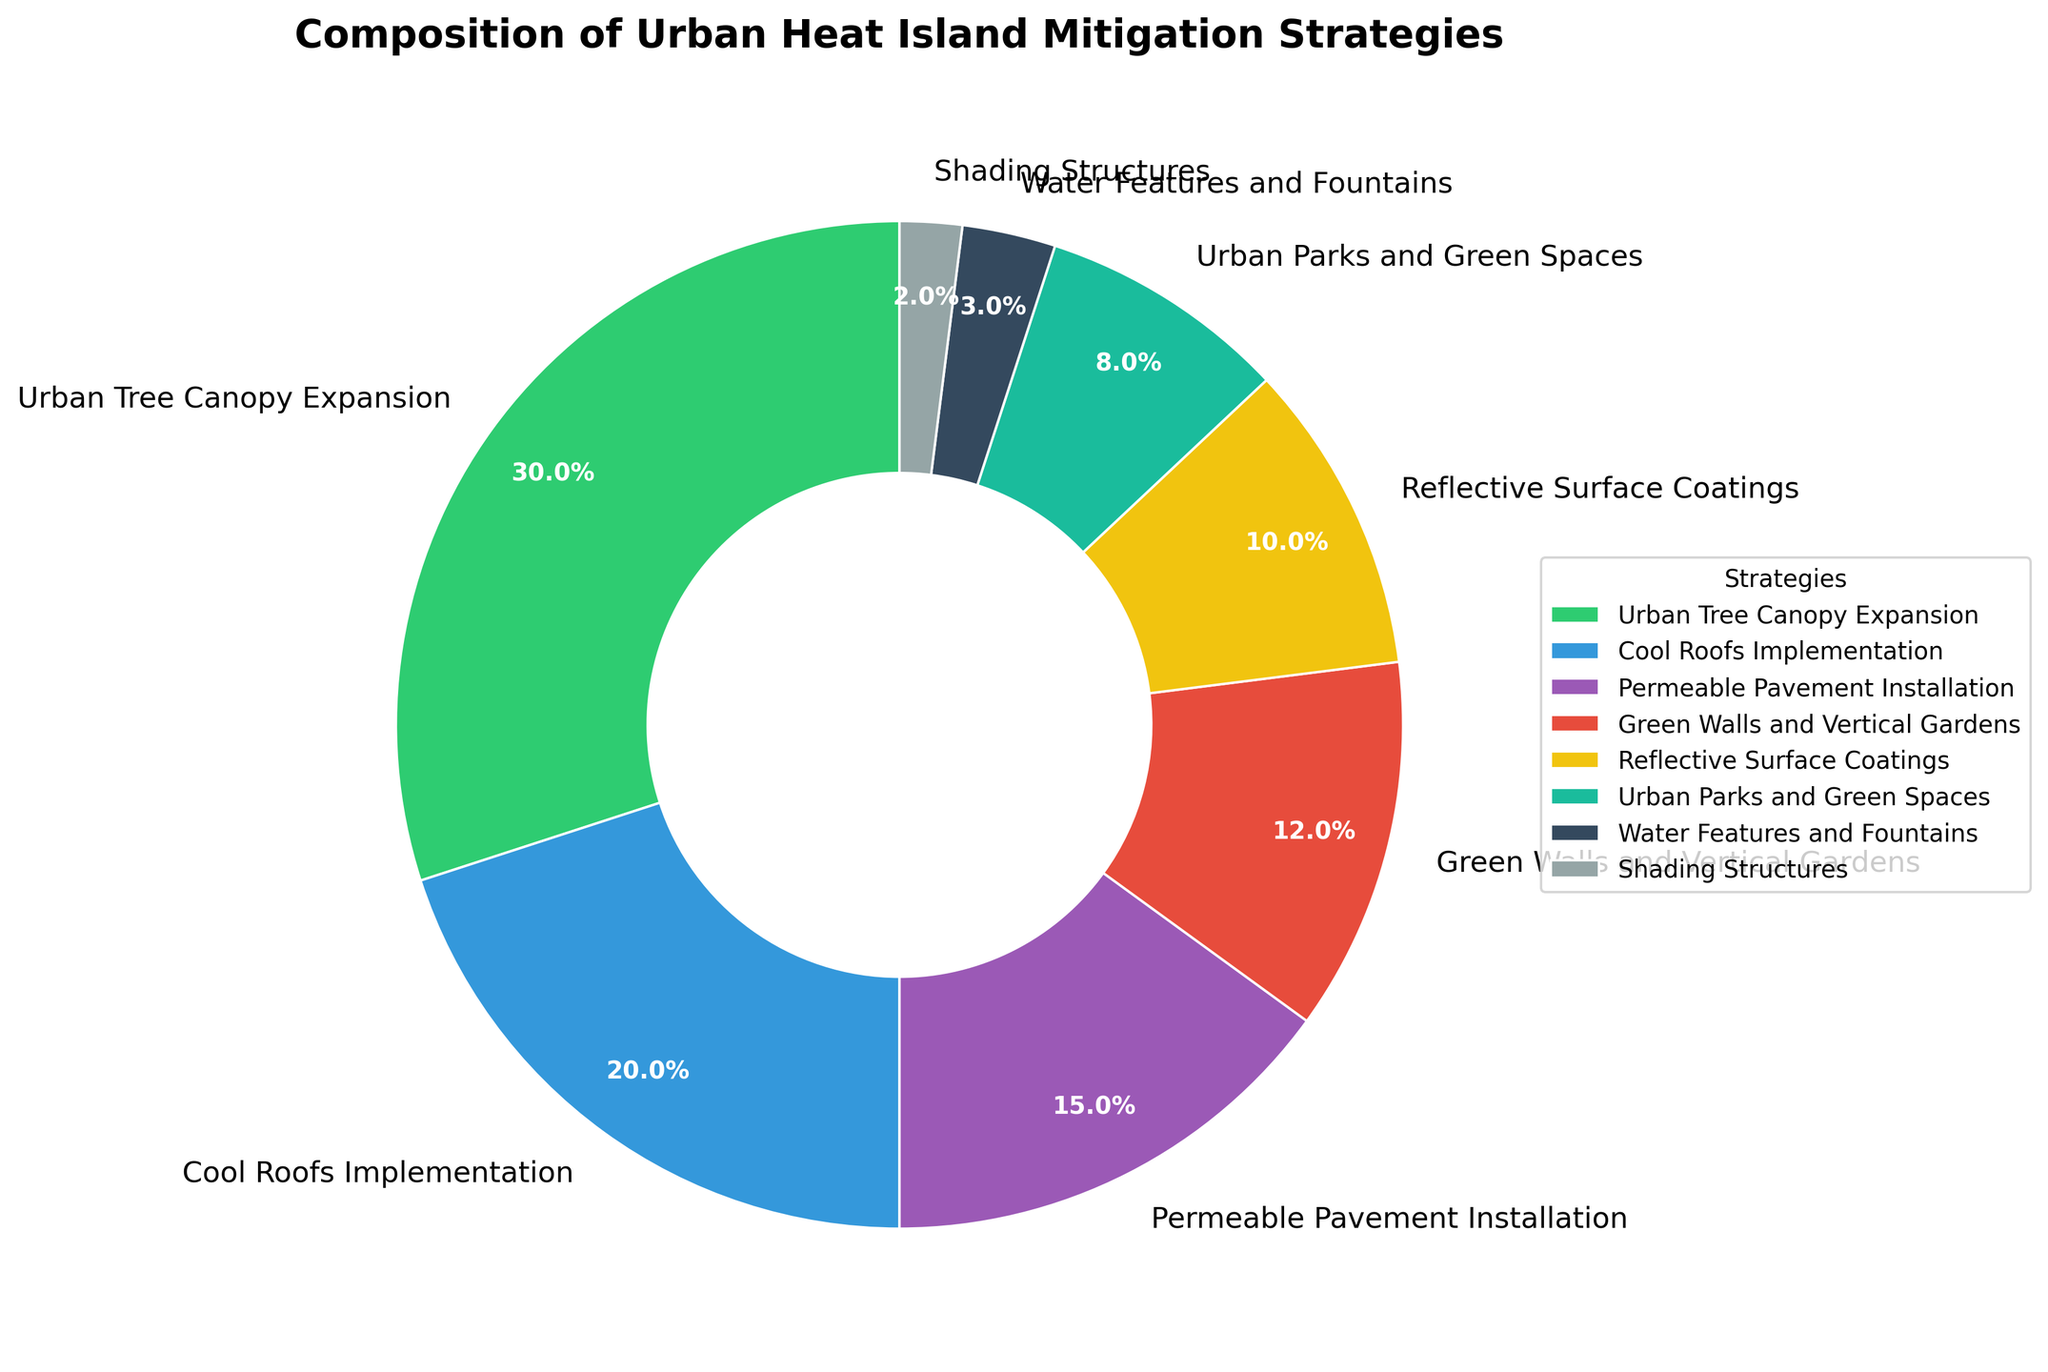What strategy represents the largest percentage of urban heat island mitigation? The visual attributes such as size and label of the pie wedges indicate percentages. The largest segment is labeled 'Urban Tree Canopy Expansion' with 30%.
Answer: Urban Tree Canopy Expansion Which two strategies combined make up less than 10%? Identify segments with the smallest percentages. 'Shading Structures' is 2% and 'Water Features and Fountains' is 3%. Adding them, 2% + 3% equals 5%, which is less than 10%.
Answer: Shading Structures and Water Features and Fountains Is the percentage of 'Cool Roofs Implementation' greater than 'Urban Parks and Green Spaces'? Compare 'Cool Roofs Implementation' at 20% directly with 'Urban Parks and Green Spaces' at 8%. 20% is greater than 8%.
Answer: Yes How much more percentage does 'Permeable Pavement Installation' have compared to 'Reflective Surface Coatings'? Subtract 'Reflective Surface Coatings' percentage from 'Permeable Pavement Installation's percentage. 15% - 10% equals 5%.
Answer: 5% Which strategies are represented by the green and blue pie segments? Identify the segments' colors related to strategies. Green is 'Urban Tree Canopy Expansion' and blue is 'Cool Roofs Implementation'.
Answer: Urban Tree Canopy Expansion and Cool Roofs Implementation What's the combined percentage of 'Green Walls and Vertical Gardens' and 'Water Features and Fountains'? Add the percentages of 'Green Walls and Vertical Gardens' at 12% and 'Water Features and Fountains' at 3%. 12% + 3% equals 15%.
Answer: 15% Are there more strategies below 10% or strategies above 10% in composition? Count the segments less than 10% and those greater or equal to 10%. Below 10%: 'Urban Parks and Green Spaces' (8%), 'Water Features and Fountains' (3%), 'Shading Structures' (2%). Above 10%: 'Urban Tree Canopy Expansion' (30%), 'Cool Roofs Implementation' (20%), 'Permeable Pavement Installation' (15%), 'Green Walls and Vertical Gardens' (12%), 'Reflective Surface Coatings' (10%). More above 10%.
Answer: Below 10% Which strategy has the smallest percentage of all the segments? The visual attributes such as size and label of the pie wedges indicate percentages. The smallest segment is labeled 'Shading Structures' with 2%.
Answer: Shading Structures What's the combined percentage of the three largest segments? Add the percentages of 'Urban Tree Canopy Expansion' at 30%, 'Cool Roofs Implementation' at 20%, and 'Permeable Pavement Installation' at 15%. 30% + 20% + 15% equals 65%.
Answer: 65% Is there any strategy with a percentage exactly equal to 10%? Check the segments' labels. 'Reflective Surface Coatings' is shown with exactly 10%.
Answer: Reflective Surface Coatings 